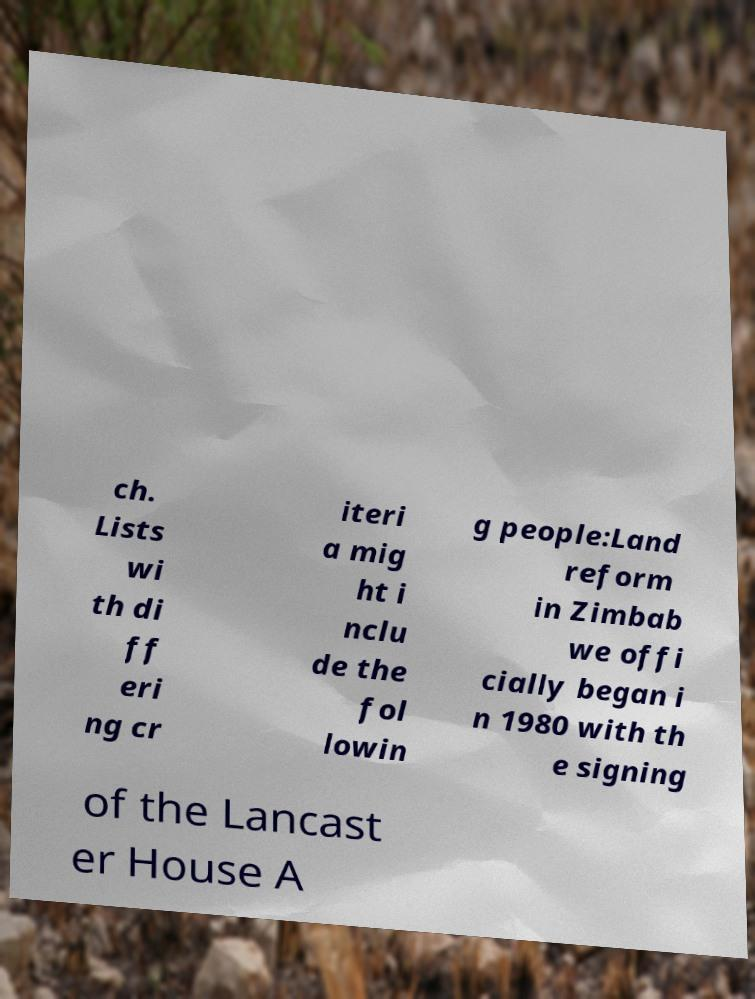Please read and relay the text visible in this image. What does it say? ch. Lists wi th di ff eri ng cr iteri a mig ht i nclu de the fol lowin g people:Land reform in Zimbab we offi cially began i n 1980 with th e signing of the Lancast er House A 